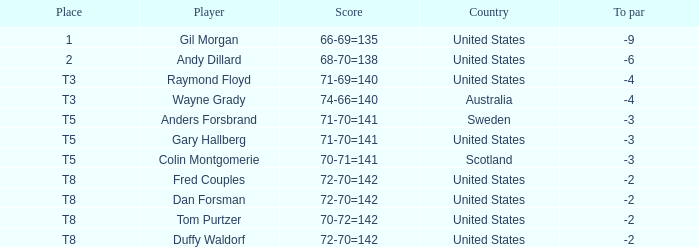What is Anders Forsbrand's Place? T5. 